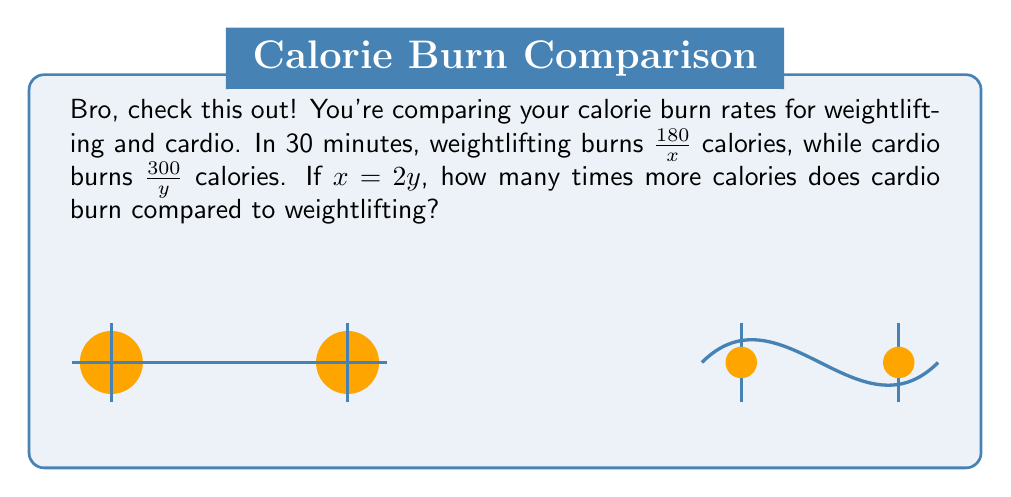Could you help me with this problem? Let's break this down, bro:

1) Weightlifting burns $\frac{180}{x}$ calories in 30 minutes
2) Cardio burns $\frac{300}{y}$ calories in 30 minutes
3) We're told that $x = 2y$

To compare, we need to find the ratio of cardio to weightlifting:

$$\frac{\text{Cardio}}{\text{Weightlifting}} = \frac{\frac{300}{y}}{\frac{180}{x}}$$

Now, let's substitute $x = 2y$ into this equation:

$$\frac{\frac{300}{y}}{\frac{180}{2y}} = \frac{300}{y} \cdot \frac{2y}{180}$$

Simplify:
$$= \frac{300 \cdot 2y}{y \cdot 180} = \frac{600}{180} = \frac{10}{3} \approx 3.33$$

So, cardio burns $\frac{10}{3}$ times more calories than weightlifting under these conditions.
Answer: $\frac{10}{3}$ 